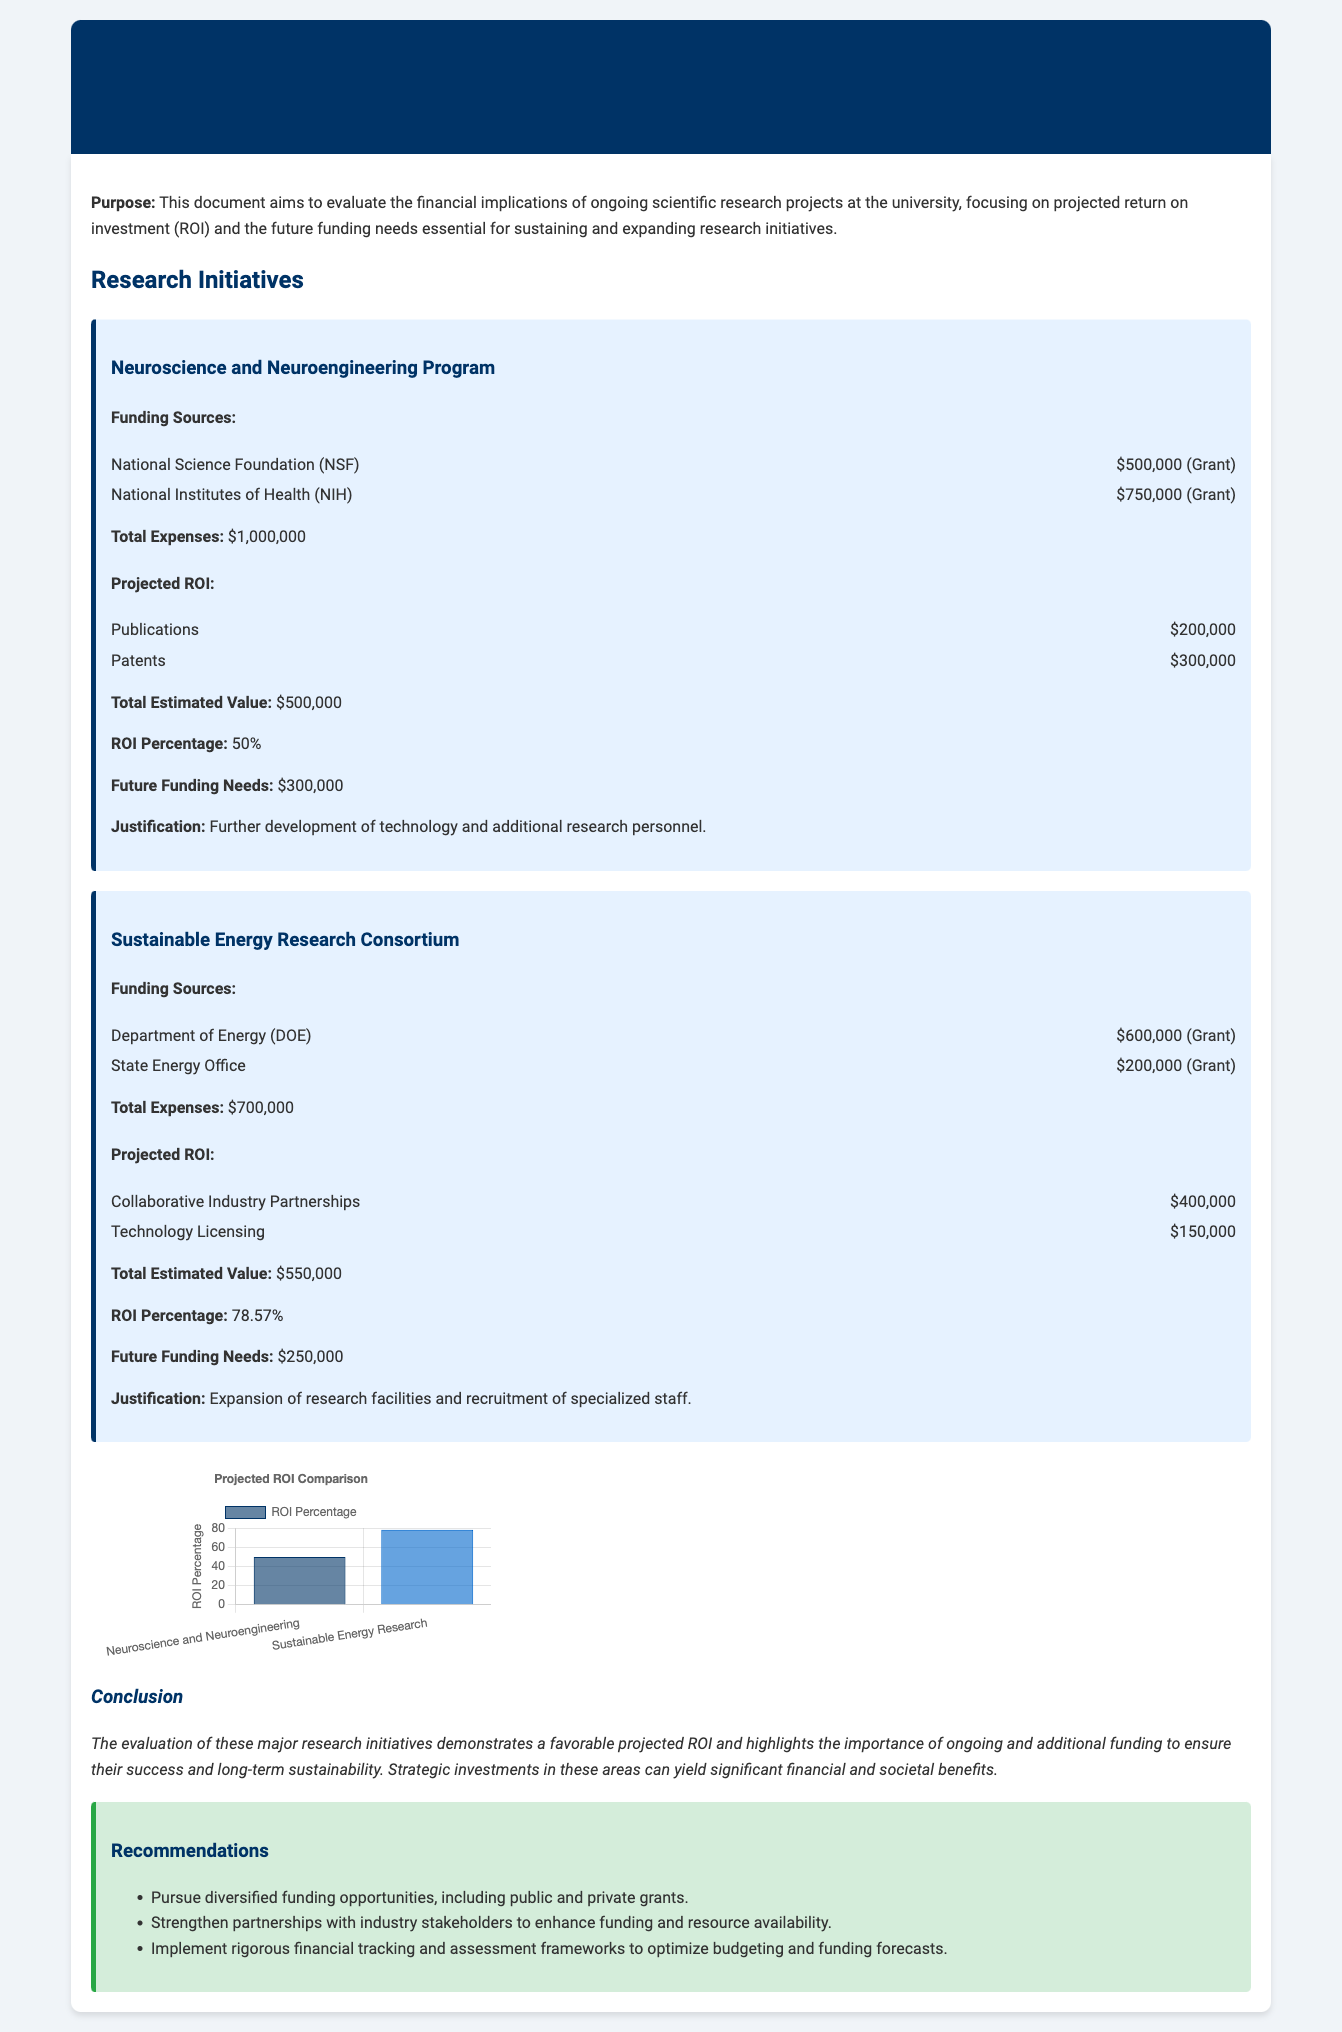What is the total funding from the National Institutes of Health? The funding from the National Institutes of Health is listed as $750,000.
Answer: $750,000 What is the total estimated value of the Neuroscience and Neuroengineering Program? The total estimated value of the Neuroscience and Neuroengineering Program is given as $500,000.
Answer: $500,000 What percentage of ROI is projected for the Sustainable Energy Research Consortium? The ROI percentage projected for the Sustainable Energy Research Consortium is explicitly stated as 78.57%.
Answer: 78.57% What is the future funding need for the Neuroscience and Neuroengineering Program? The future funding need for the Neuroscience and Neuroengineering Program is mentioned as $300,000.
Answer: $300,000 What justification is given for the future funding needs of the Sustainable Energy Research Consortium? The justification for the future funding needs is for expansion of research facilities and recruitment of specialized staff.
Answer: Expansion of research facilities and recruitment of specialized staff What are the two major funding sources for the Sustainable Energy Research Consortium? The two major funding sources for the Sustainable Energy Research Consortium are the Department of Energy and the State Energy Office.
Answer: Department of Energy, State Energy Office What should be pursued according to the recommendations in the document? According to the recommendations, diversified funding opportunities should be pursued.
Answer: Diversified funding opportunities What is the main conclusion of the financial impact assessment? The main conclusion of the financial impact assessment highlights the importance of ongoing and additional funding for success and sustainability.
Answer: Importance of ongoing and additional funding for success and sustainability 